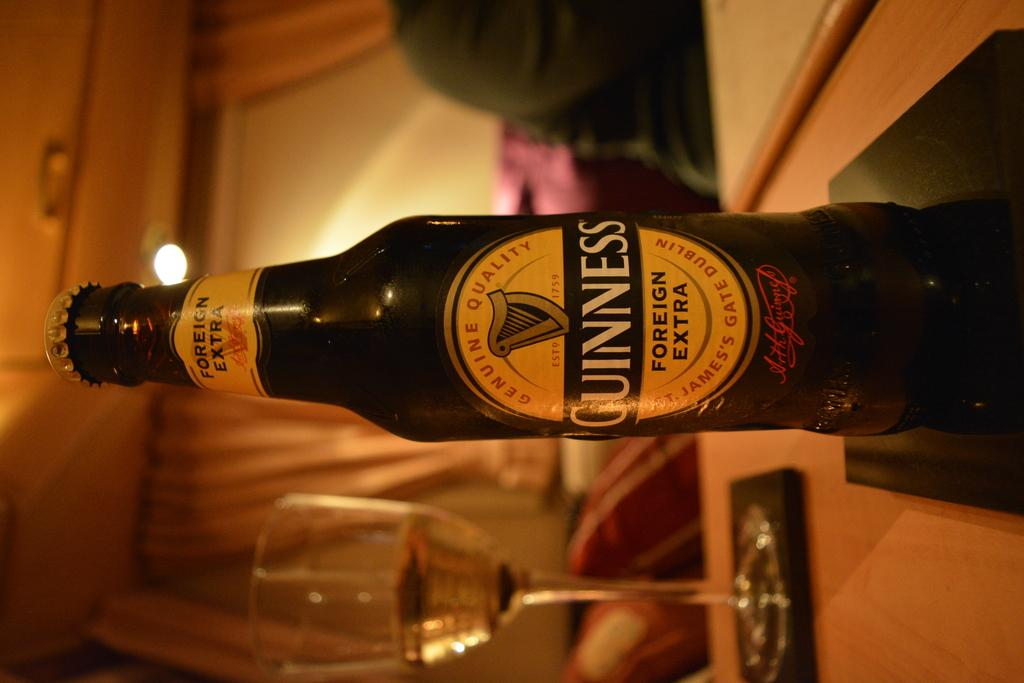Provide a one-sentence caption for the provided image. A bottle of Guinness beer is on top of a coaster next to a stemmed glass. 